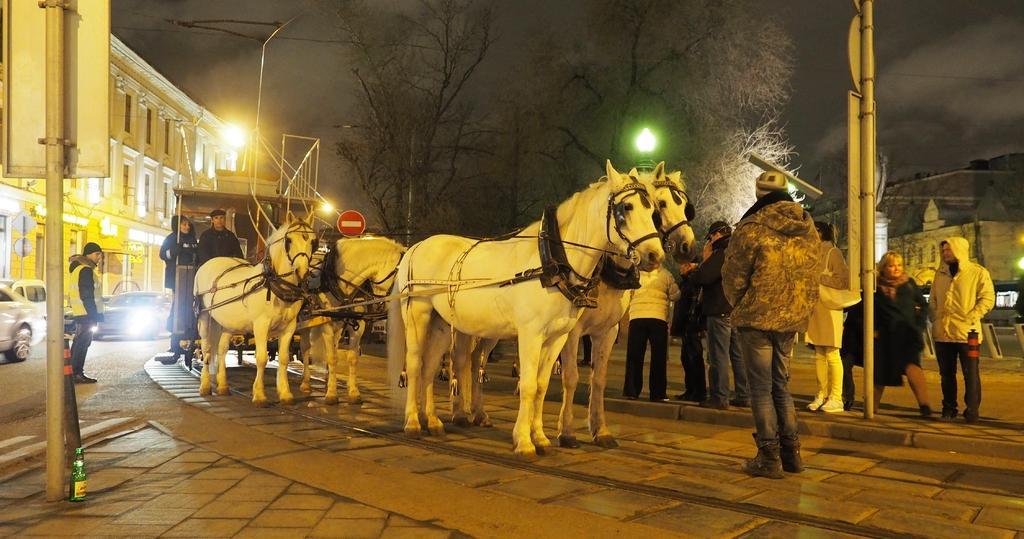Can you describe this image briefly? Here we can see a group of Horses and behind them there is a trolley having people in it and in front of them there are group of people standing and there are cars present and there is a building present and there are trees present and there are lights present 